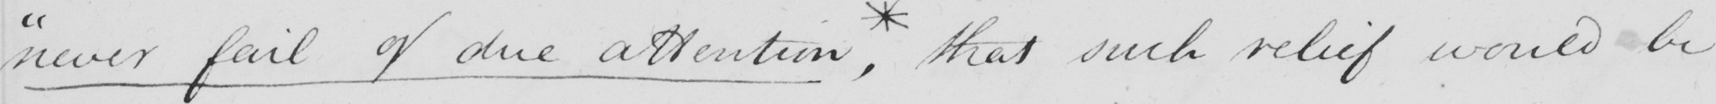What is written in this line of handwriting? " never fail of due attention , * that such relief would be 